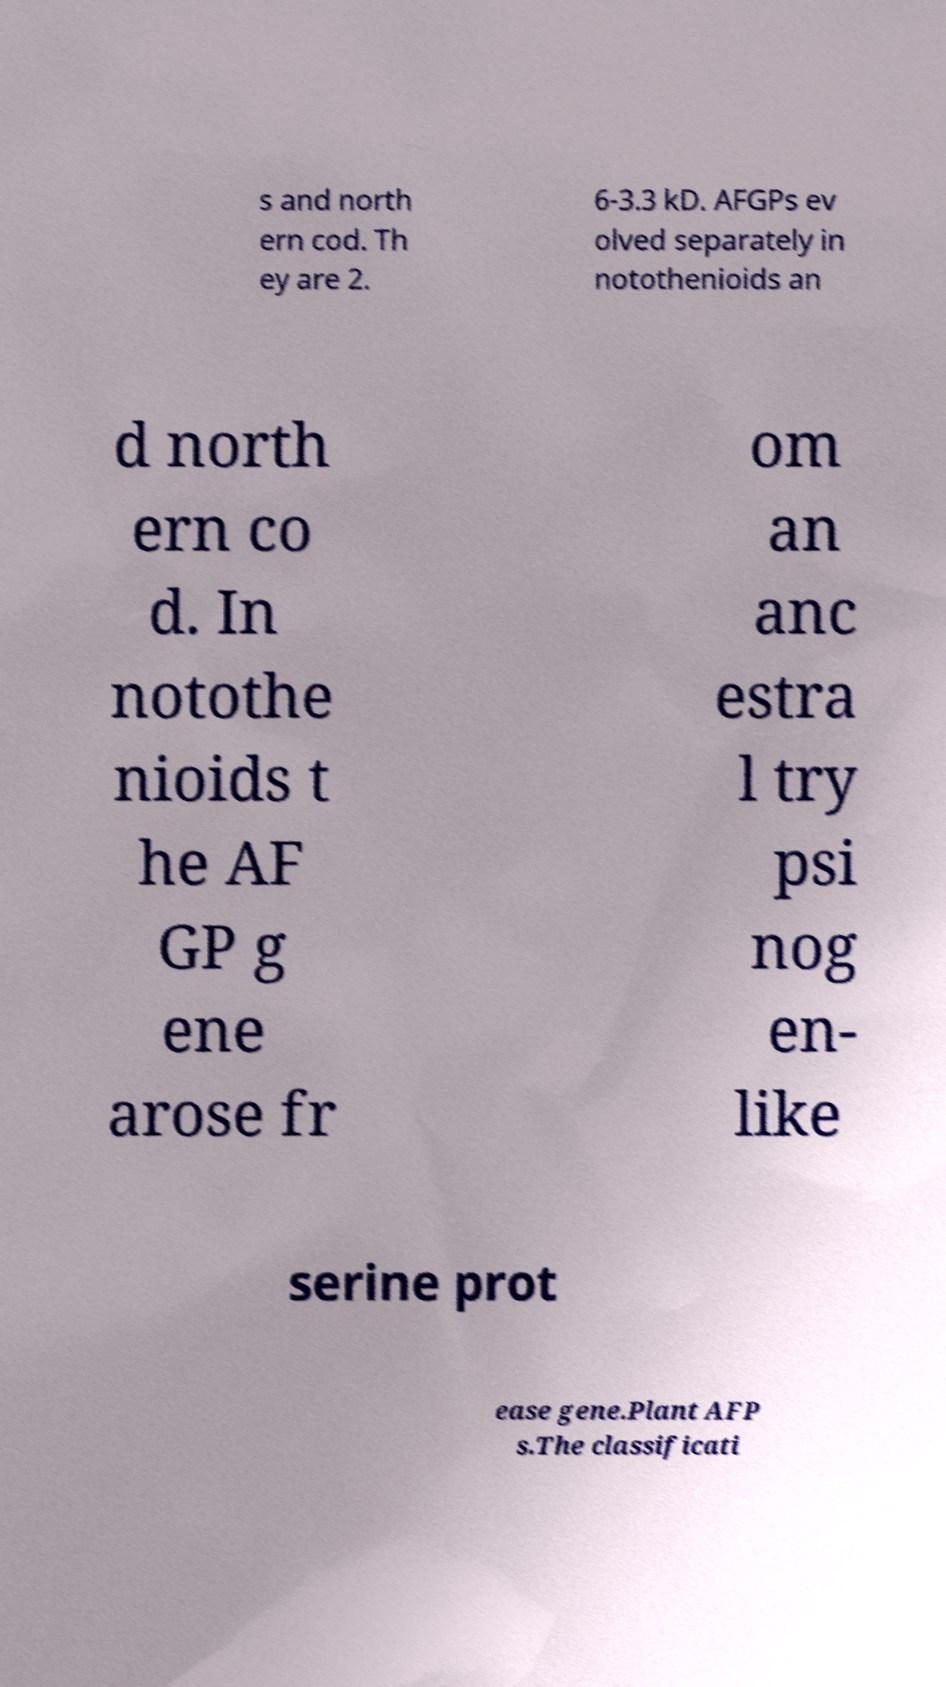Could you assist in decoding the text presented in this image and type it out clearly? s and north ern cod. Th ey are 2. 6-3.3 kD. AFGPs ev olved separately in notothenioids an d north ern co d. In notothe nioids t he AF GP g ene arose fr om an anc estra l try psi nog en- like serine prot ease gene.Plant AFP s.The classificati 